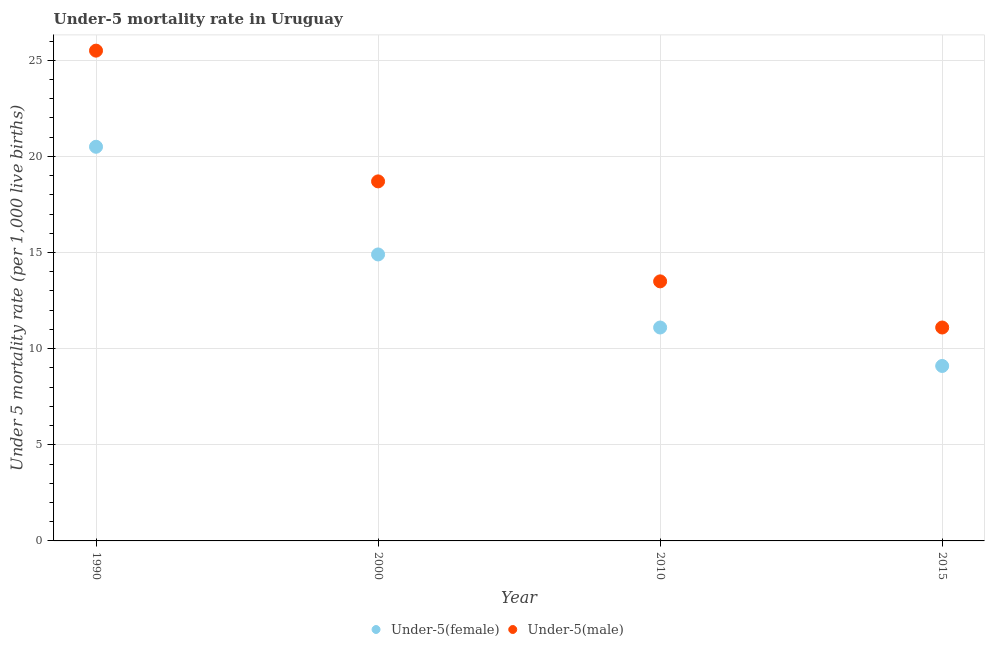Is the number of dotlines equal to the number of legend labels?
Your answer should be very brief. Yes. What is the under-5 female mortality rate in 2015?
Provide a short and direct response. 9.1. Across all years, what is the maximum under-5 male mortality rate?
Keep it short and to the point. 25.5. Across all years, what is the minimum under-5 male mortality rate?
Give a very brief answer. 11.1. In which year was the under-5 female mortality rate maximum?
Ensure brevity in your answer.  1990. In which year was the under-5 male mortality rate minimum?
Provide a short and direct response. 2015. What is the total under-5 female mortality rate in the graph?
Provide a succinct answer. 55.6. What is the difference between the under-5 female mortality rate in 2000 and that in 2010?
Make the answer very short. 3.8. What is the difference between the under-5 male mortality rate in 2010 and the under-5 female mortality rate in 2000?
Provide a succinct answer. -1.4. What is the average under-5 female mortality rate per year?
Give a very brief answer. 13.9. In the year 1990, what is the difference between the under-5 male mortality rate and under-5 female mortality rate?
Offer a terse response. 5. In how many years, is the under-5 male mortality rate greater than 21?
Make the answer very short. 1. What is the ratio of the under-5 male mortality rate in 1990 to that in 2010?
Give a very brief answer. 1.89. What is the difference between the highest and the second highest under-5 male mortality rate?
Give a very brief answer. 6.8. What is the difference between the highest and the lowest under-5 female mortality rate?
Offer a very short reply. 11.4. Does the under-5 male mortality rate monotonically increase over the years?
Ensure brevity in your answer.  No. Is the under-5 female mortality rate strictly less than the under-5 male mortality rate over the years?
Make the answer very short. Yes. What is the difference between two consecutive major ticks on the Y-axis?
Provide a short and direct response. 5. Are the values on the major ticks of Y-axis written in scientific E-notation?
Offer a terse response. No. Does the graph contain grids?
Ensure brevity in your answer.  Yes. How many legend labels are there?
Your answer should be very brief. 2. How are the legend labels stacked?
Your response must be concise. Horizontal. What is the title of the graph?
Provide a succinct answer. Under-5 mortality rate in Uruguay. Does "Exports" appear as one of the legend labels in the graph?
Your answer should be very brief. No. What is the label or title of the Y-axis?
Offer a very short reply. Under 5 mortality rate (per 1,0 live births). What is the Under 5 mortality rate (per 1,000 live births) in Under-5(male) in 1990?
Offer a very short reply. 25.5. What is the Under 5 mortality rate (per 1,000 live births) of Under-5(female) in 2000?
Your answer should be compact. 14.9. What is the Under 5 mortality rate (per 1,000 live births) of Under-5(male) in 2000?
Offer a very short reply. 18.7. What is the Under 5 mortality rate (per 1,000 live births) of Under-5(female) in 2010?
Give a very brief answer. 11.1. What is the Under 5 mortality rate (per 1,000 live births) in Under-5(female) in 2015?
Ensure brevity in your answer.  9.1. What is the Under 5 mortality rate (per 1,000 live births) of Under-5(male) in 2015?
Your answer should be very brief. 11.1. Across all years, what is the maximum Under 5 mortality rate (per 1,000 live births) in Under-5(male)?
Offer a terse response. 25.5. Across all years, what is the minimum Under 5 mortality rate (per 1,000 live births) of Under-5(female)?
Your answer should be very brief. 9.1. What is the total Under 5 mortality rate (per 1,000 live births) of Under-5(female) in the graph?
Give a very brief answer. 55.6. What is the total Under 5 mortality rate (per 1,000 live births) of Under-5(male) in the graph?
Provide a succinct answer. 68.8. What is the difference between the Under 5 mortality rate (per 1,000 live births) in Under-5(female) in 1990 and that in 2000?
Your response must be concise. 5.6. What is the difference between the Under 5 mortality rate (per 1,000 live births) of Under-5(male) in 1990 and that in 2000?
Your answer should be compact. 6.8. What is the difference between the Under 5 mortality rate (per 1,000 live births) in Under-5(female) in 1990 and that in 2015?
Provide a short and direct response. 11.4. What is the difference between the Under 5 mortality rate (per 1,000 live births) of Under-5(male) in 1990 and that in 2015?
Ensure brevity in your answer.  14.4. What is the difference between the Under 5 mortality rate (per 1,000 live births) of Under-5(male) in 2000 and that in 2010?
Ensure brevity in your answer.  5.2. What is the difference between the Under 5 mortality rate (per 1,000 live births) in Under-5(female) in 1990 and the Under 5 mortality rate (per 1,000 live births) in Under-5(male) in 2010?
Keep it short and to the point. 7. What is the difference between the Under 5 mortality rate (per 1,000 live births) in Under-5(female) in 2000 and the Under 5 mortality rate (per 1,000 live births) in Under-5(male) in 2010?
Make the answer very short. 1.4. What is the difference between the Under 5 mortality rate (per 1,000 live births) of Under-5(female) in 2000 and the Under 5 mortality rate (per 1,000 live births) of Under-5(male) in 2015?
Offer a terse response. 3.8. What is the average Under 5 mortality rate (per 1,000 live births) of Under-5(female) per year?
Offer a very short reply. 13.9. In the year 2010, what is the difference between the Under 5 mortality rate (per 1,000 live births) in Under-5(female) and Under 5 mortality rate (per 1,000 live births) in Under-5(male)?
Offer a terse response. -2.4. What is the ratio of the Under 5 mortality rate (per 1,000 live births) of Under-5(female) in 1990 to that in 2000?
Offer a very short reply. 1.38. What is the ratio of the Under 5 mortality rate (per 1,000 live births) in Under-5(male) in 1990 to that in 2000?
Your response must be concise. 1.36. What is the ratio of the Under 5 mortality rate (per 1,000 live births) of Under-5(female) in 1990 to that in 2010?
Provide a succinct answer. 1.85. What is the ratio of the Under 5 mortality rate (per 1,000 live births) of Under-5(male) in 1990 to that in 2010?
Provide a short and direct response. 1.89. What is the ratio of the Under 5 mortality rate (per 1,000 live births) of Under-5(female) in 1990 to that in 2015?
Make the answer very short. 2.25. What is the ratio of the Under 5 mortality rate (per 1,000 live births) in Under-5(male) in 1990 to that in 2015?
Your response must be concise. 2.3. What is the ratio of the Under 5 mortality rate (per 1,000 live births) in Under-5(female) in 2000 to that in 2010?
Provide a succinct answer. 1.34. What is the ratio of the Under 5 mortality rate (per 1,000 live births) of Under-5(male) in 2000 to that in 2010?
Provide a short and direct response. 1.39. What is the ratio of the Under 5 mortality rate (per 1,000 live births) in Under-5(female) in 2000 to that in 2015?
Offer a terse response. 1.64. What is the ratio of the Under 5 mortality rate (per 1,000 live births) of Under-5(male) in 2000 to that in 2015?
Offer a terse response. 1.68. What is the ratio of the Under 5 mortality rate (per 1,000 live births) in Under-5(female) in 2010 to that in 2015?
Your answer should be very brief. 1.22. What is the ratio of the Under 5 mortality rate (per 1,000 live births) of Under-5(male) in 2010 to that in 2015?
Your response must be concise. 1.22. What is the difference between the highest and the second highest Under 5 mortality rate (per 1,000 live births) of Under-5(female)?
Provide a short and direct response. 5.6. What is the difference between the highest and the second highest Under 5 mortality rate (per 1,000 live births) in Under-5(male)?
Give a very brief answer. 6.8. What is the difference between the highest and the lowest Under 5 mortality rate (per 1,000 live births) of Under-5(female)?
Give a very brief answer. 11.4. 